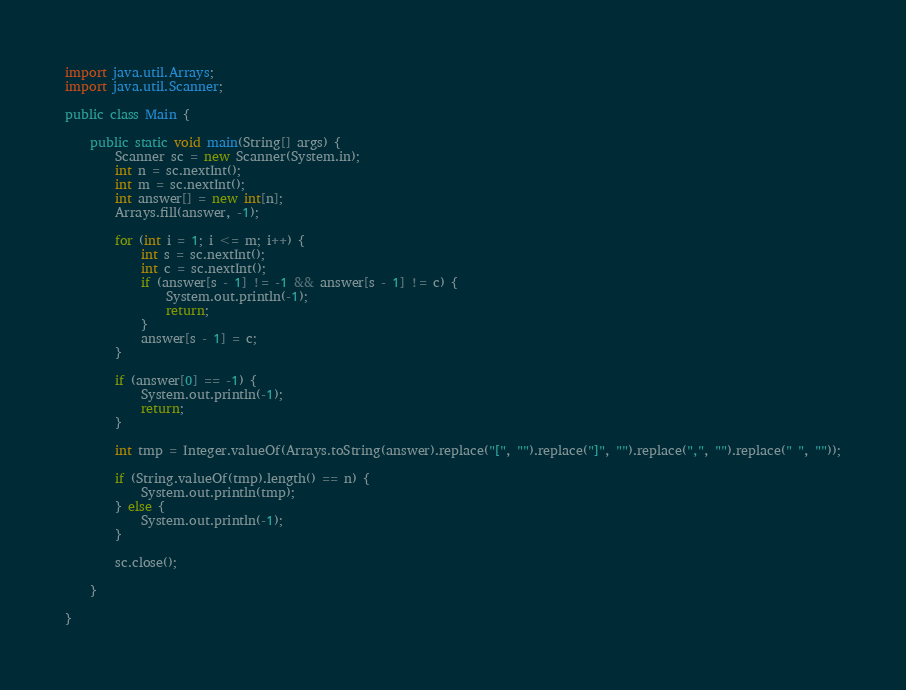Convert code to text. <code><loc_0><loc_0><loc_500><loc_500><_Java_>import java.util.Arrays;
import java.util.Scanner;

public class Main {

	public static void main(String[] args) {
		Scanner sc = new Scanner(System.in);
		int n = sc.nextInt();
		int m = sc.nextInt();
		int answer[] = new int[n];
		Arrays.fill(answer, -1);

		for (int i = 1; i <= m; i++) {
			int s = sc.nextInt();
			int c = sc.nextInt();
			if (answer[s - 1] != -1 && answer[s - 1] != c) {
				System.out.println(-1);
				return;
			}
			answer[s - 1] = c;
		}

		if (answer[0] == -1) {
			System.out.println(-1);
			return;
		}

		int tmp = Integer.valueOf(Arrays.toString(answer).replace("[", "").replace("]", "").replace(",", "").replace(" ", ""));

		if (String.valueOf(tmp).length() == n) {
			System.out.println(tmp);
		} else {
			System.out.println(-1);
		}

		sc.close();

	}

}
</code> 